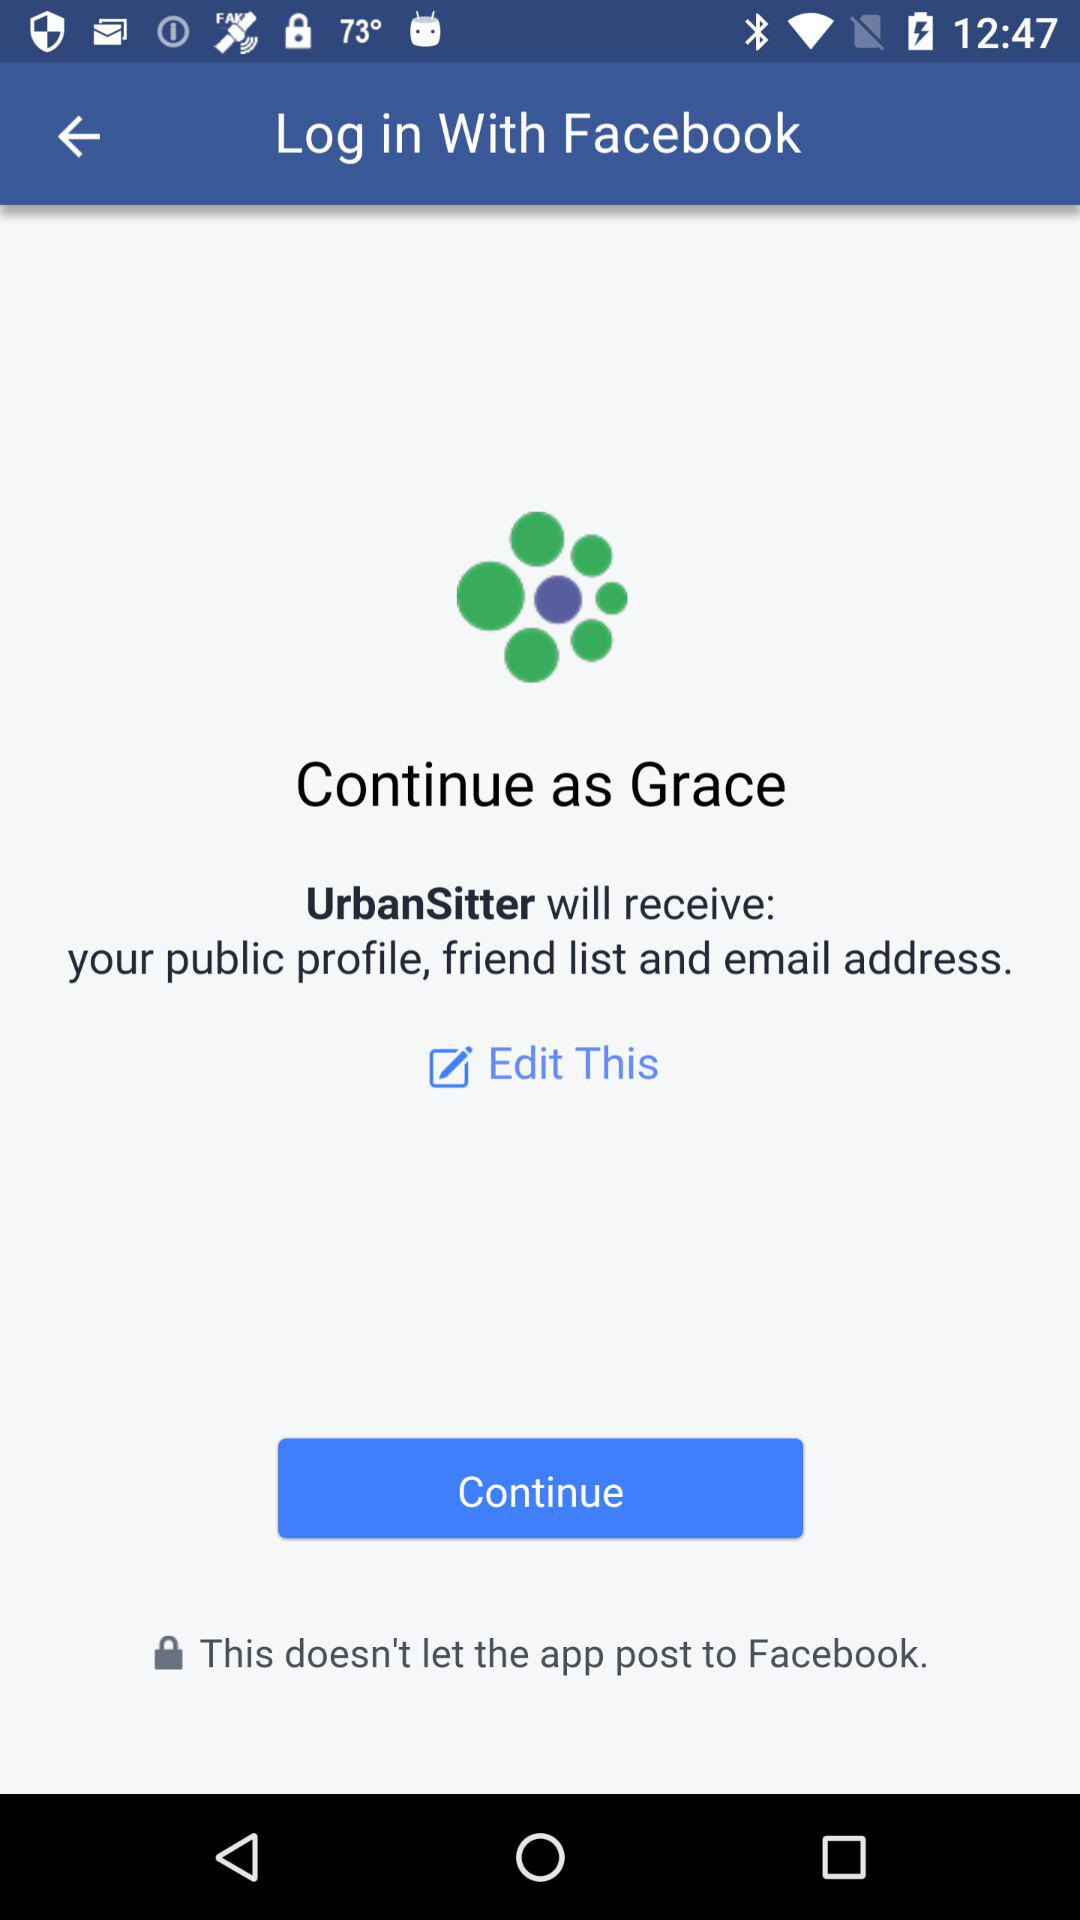How can we log in? You can log in with "Facebook". 